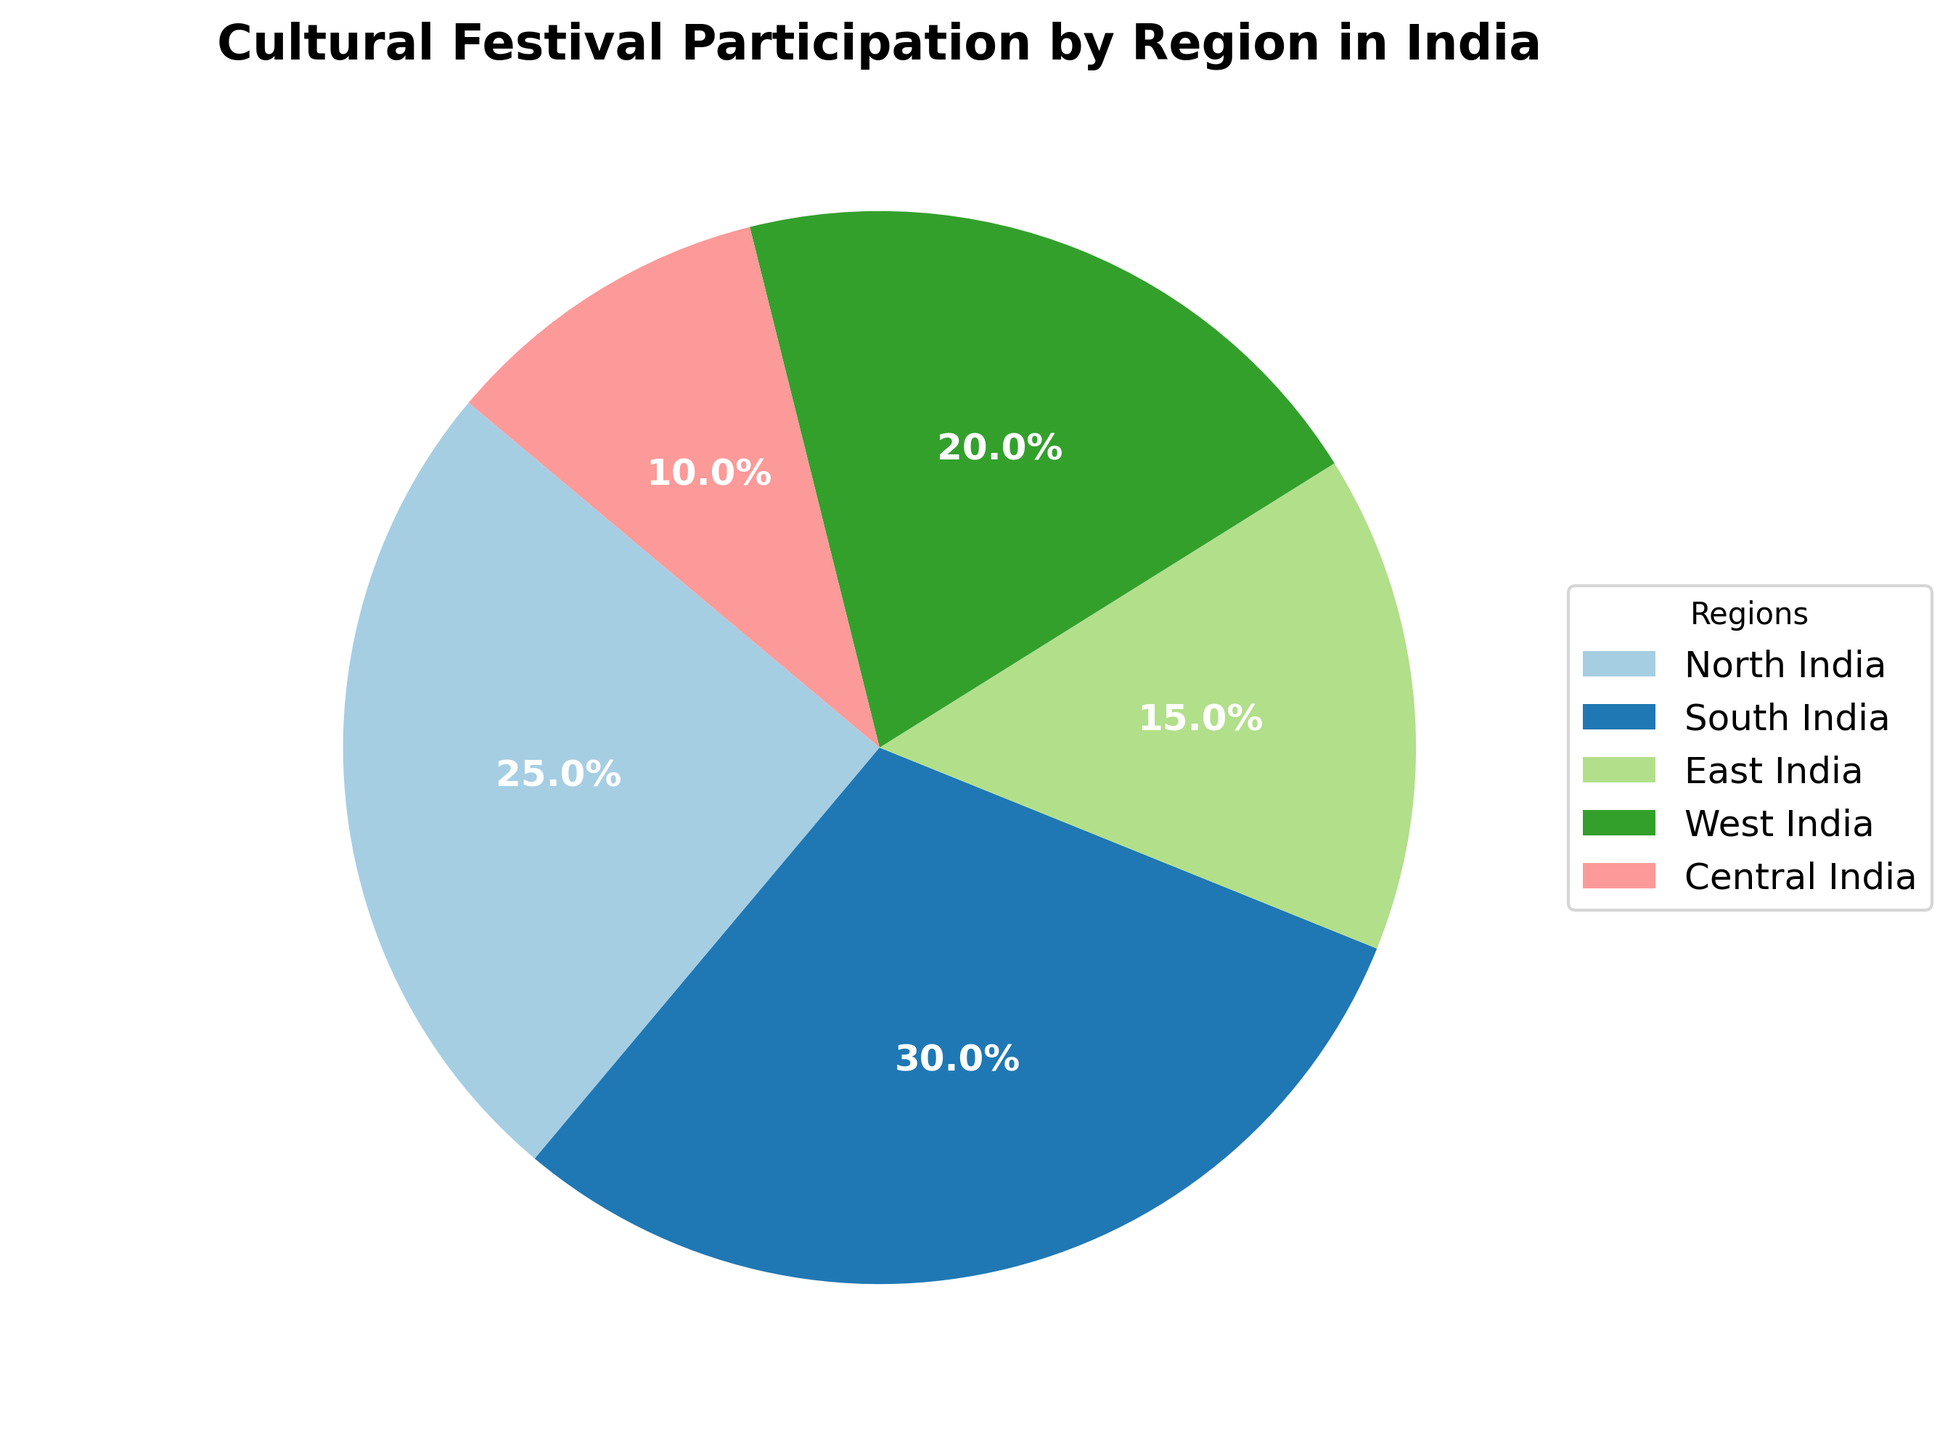What's the percentage of participation from South India? The pie chart shows the percentage labels for each region. Looking at the segment labeled "South India," the percentage is given as 30%.
Answer: 30% Which region has the lowest participation? From the pie chart, we can compare the percentages listed for each region. The smallest percentage is given for "Central India" at 10%.
Answer: Central India How much greater is the participation in West India compared to East India? West India has a 20% participation rate, while East India has a 15% participation rate. The difference is calculated as 20% - 15% = 5%.
Answer: 5% Which two regions have the highest participation and what is their combined percentage? The regions with the highest participation are South India (30%) and North India (25%). Their combined percentage is 30% + 25% = 55%.
Answer: South India and North India, 55% What percentage of participation comes from regions other than South India? To find the percentage from regions other than South India, sum the percentages of the other regions: North India (25%) + East India (15%) + West India (20%) + Central India (10%) = 70%.
Answer: 70% What is the average participation percentage across all regions? To find the average, sum all the percentages and divide by the number of regions. The total sum is 25% (North) + 30% (South) + 15% (East) + 20% (West) + 10% (Central) = 100%. The average is 100% / 5 regions = 20%.
Answer: 20% Is the participation of South India more than twice the participation of Central India? South India has 30% participation, and Central India has 10% participation. To check if 30% is more than twice 10%, compute 2 * 10% = 20%. Since 30% > 20%, South India's participation is indeed more than twice that of Central India.
Answer: Yes If Central and East India were combined into one region, what would their total percentage be, and how would it compare to West India? Combine the percentages of Central India (10%) and East India (15%): 10% + 15% = 25%. Compare this to West India's 20%; 25% is greater than 20%.
Answer: 25%, greater than West India What is the ratio of participation between South India and North India? South India has 30% participation, and North India has 25%. The ratio is 30% : 25% which simplifies to 6 : 5.
Answer: 6:5 Which region's participation is closest to the average participation percentage? The average participation is 20%. Comparing this with each region, North India (25%), South India (30%), East India (15%), West India (20%), Central India (10%), West India's 20% is exactly the average.
Answer: West India 